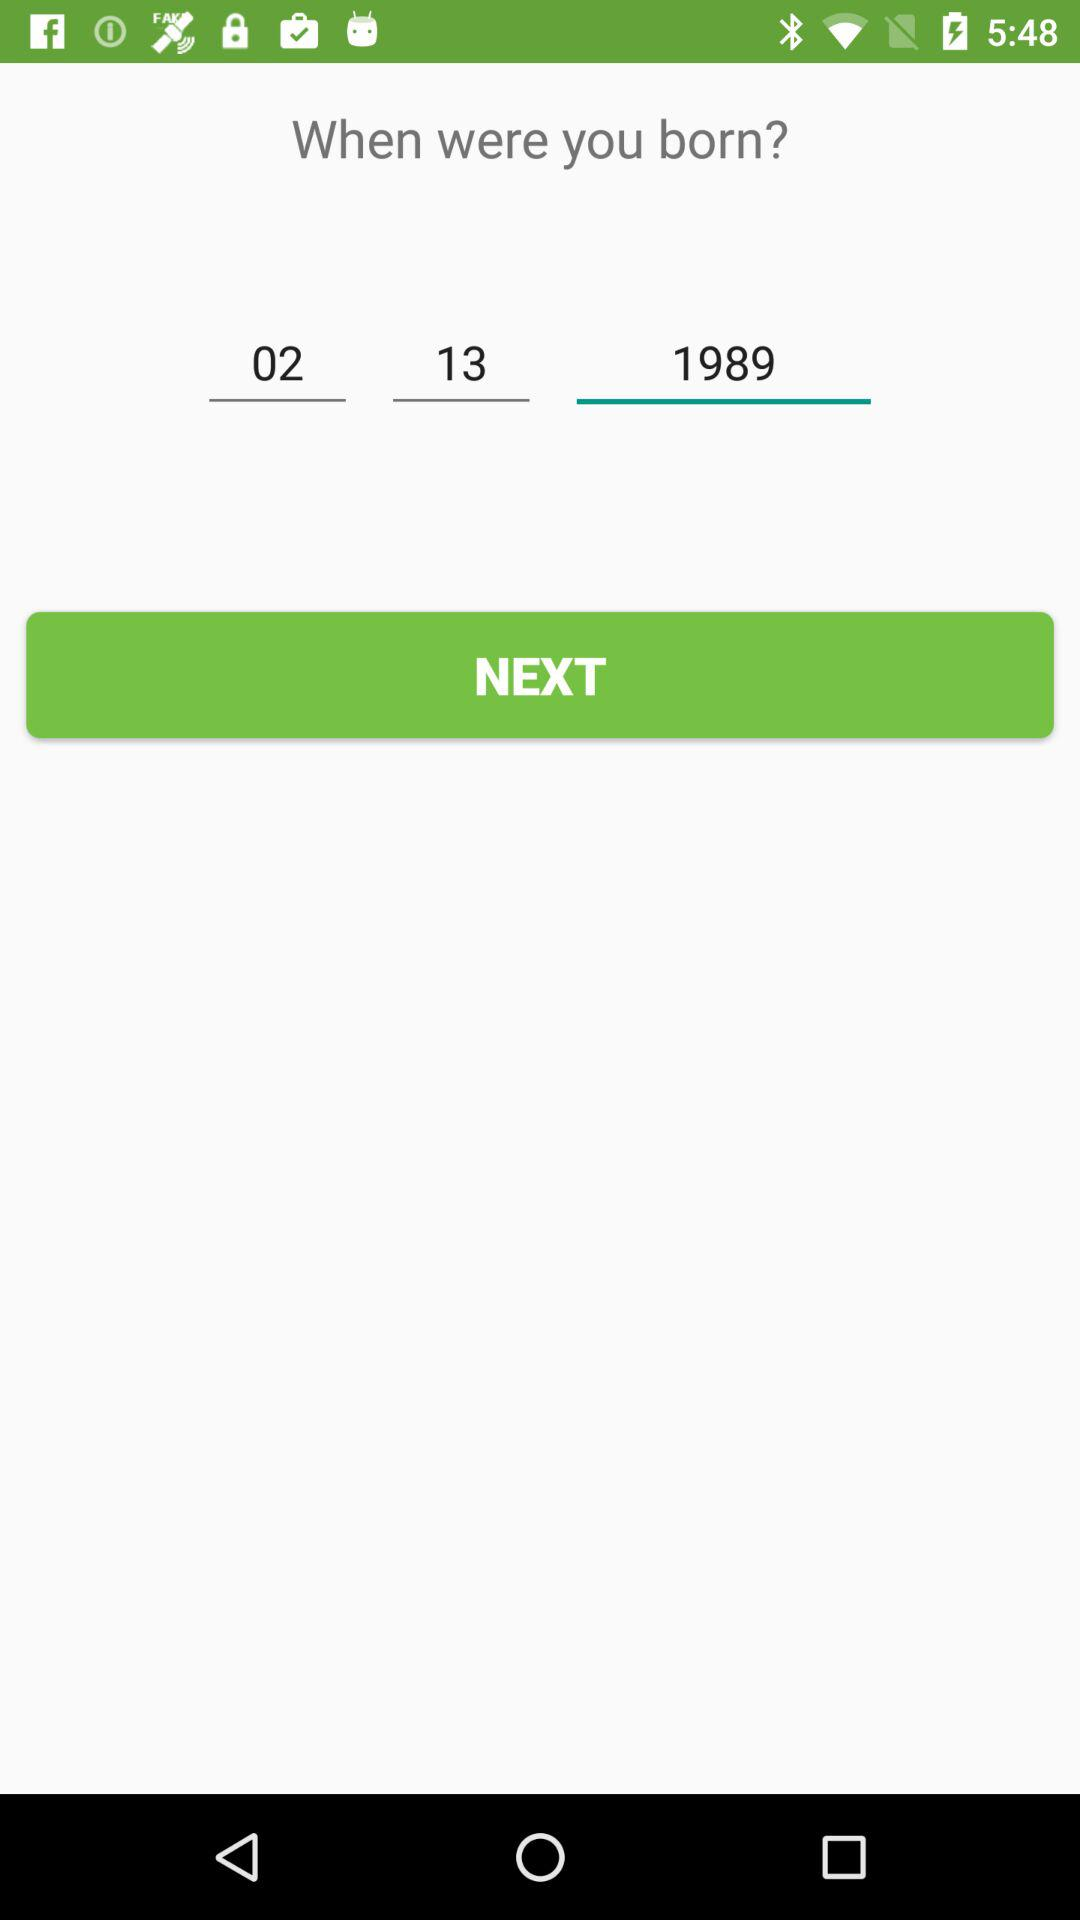What is the selected date as the date of birth? The selected date is February 13, 1989. 